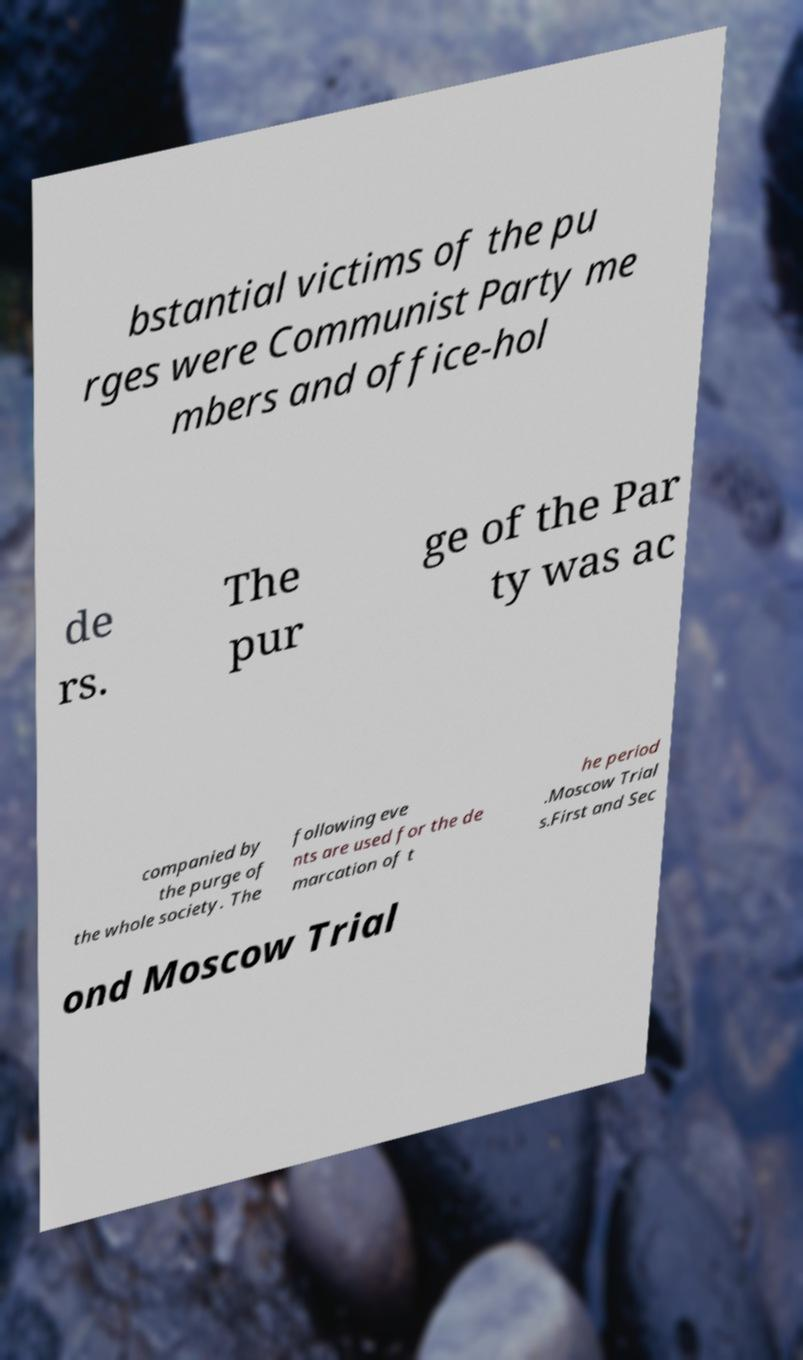Please read and relay the text visible in this image. What does it say? bstantial victims of the pu rges were Communist Party me mbers and office-hol de rs. The pur ge of the Par ty was ac companied by the purge of the whole society. The following eve nts are used for the de marcation of t he period .Moscow Trial s.First and Sec ond Moscow Trial 